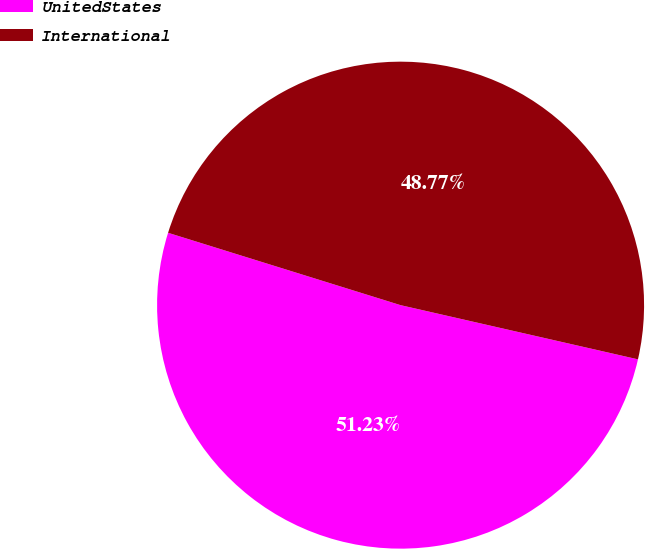<chart> <loc_0><loc_0><loc_500><loc_500><pie_chart><fcel>UnitedStates<fcel>International<nl><fcel>51.23%<fcel>48.77%<nl></chart> 